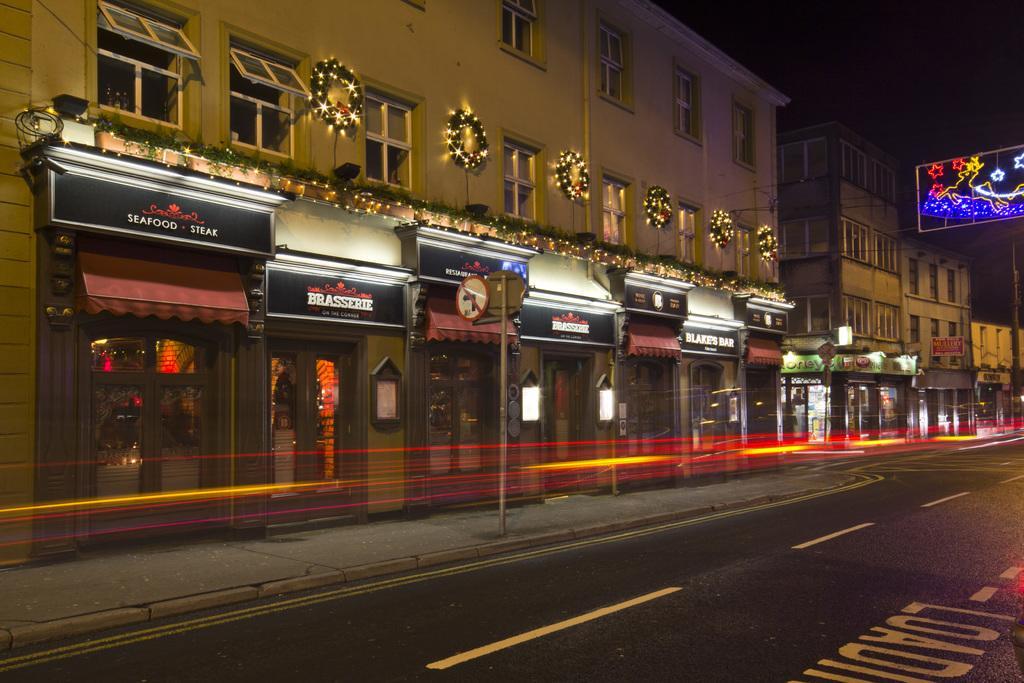Can you describe this image briefly? This picture is clicked outside the city. At the bottom of the picture, we see the road. Beside that, we see a pole. On the left side, we see a building which is decorated with lights. It has glass doors and windows. We see black color boards with some text written on it. There are buildings in the background. On the right side, we see a board which is decorated with lights. 